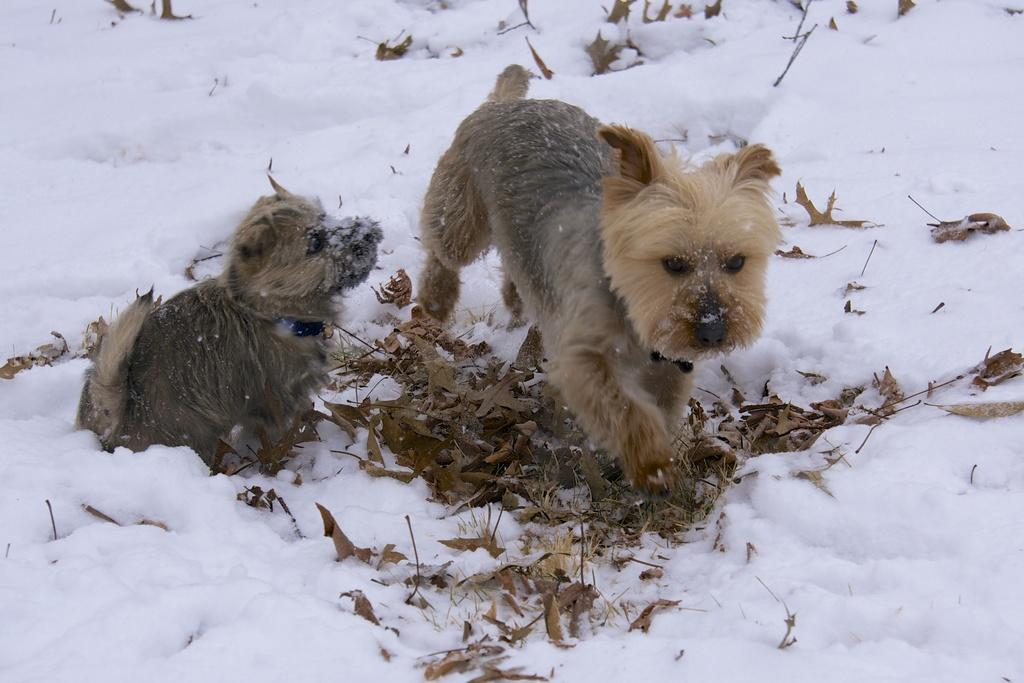How many dogs are in the image? There are 2 dogs in the image. What are the colors of the dogs? One dog is grey in color, and the other dog is cream in color. What is the ground covered with in the image? There is white snow in the image, and dried leaves are present on the snow. How many pizzas are being served during the recess in the image? There is no mention of pizzas or a recess in the image; it features two dogs and snowy ground with dried leaves. 